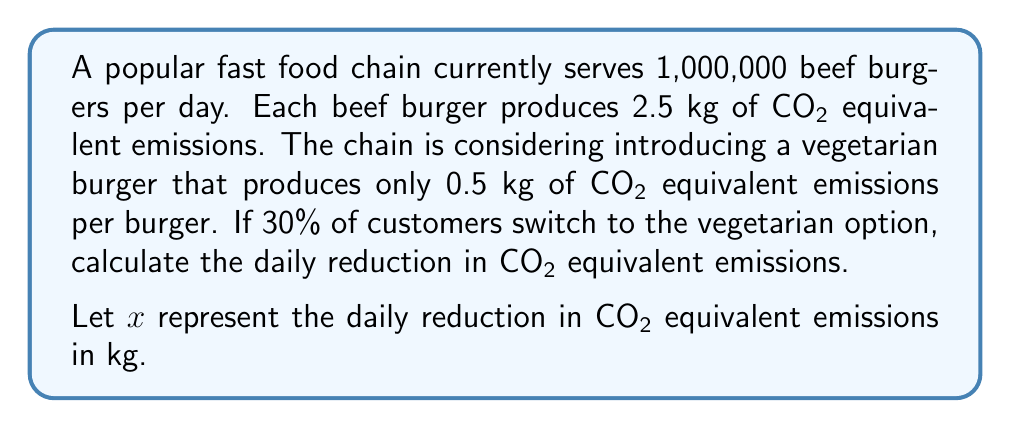Help me with this question. To solve this problem, we'll follow these steps:

1. Calculate the current daily emissions:
   $$E_{current} = 1,000,000 \times 2.5 = 2,500,000 \text{ kg CO2}$$

2. Calculate the number of customers switching to vegetarian options:
   $$N_{veg} = 30\% \times 1,000,000 = 0.3 \times 1,000,000 = 300,000$$

3. Calculate the new daily emissions:
   - Remaining beef burgers: $700,000 \times 2.5 = 1,750,000 \text{ kg CO2}$
   - New vegetarian burgers: $300,000 \times 0.5 = 150,000 \text{ kg CO2}$
   $$E_{new} = 1,750,000 + 150,000 = 1,900,000 \text{ kg CO2}$$

4. Calculate the daily reduction in emissions:
   $$x = E_{current} - E_{new} = 2,500,000 - 1,900,000 = 600,000 \text{ kg CO2}$$

Therefore, the daily reduction in CO2 equivalent emissions is 600,000 kg.
Answer: $x = 600,000 \text{ kg CO2}$ 